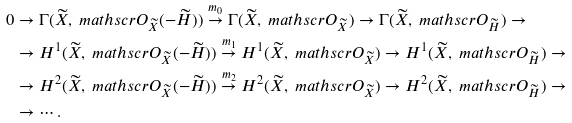<formula> <loc_0><loc_0><loc_500><loc_500>0 & \to \Gamma ( \widetilde { X } , \ m a t h s c r { O } _ { \widetilde { X } } ( - \widetilde { H } ) ) \overset { m _ { 0 } } { \to } \Gamma ( \widetilde { X } , \ m a t h s c r { O } _ { \widetilde { X } } ) \to \Gamma ( \widetilde { X } , \ m a t h s c r { O } _ { \widetilde { H } } ) \to \\ & \to H ^ { 1 } ( \widetilde { X } , \ m a t h s c r { O } _ { \widetilde { X } } ( - \widetilde { H } ) ) \overset { m _ { 1 } } { \to } H ^ { 1 } ( \widetilde { X } , \ m a t h s c r { O } _ { \widetilde { X } } ) \to H ^ { 1 } ( \widetilde { X } , \ m a t h s c r { O } _ { \widetilde { H } } ) \to \\ & \to H ^ { 2 } ( \widetilde { X } , \ m a t h s c r { O } _ { \widetilde { X } } ( - \widetilde { H } ) ) \overset { m _ { 2 } } { \to } H ^ { 2 } ( \widetilde { X } , \ m a t h s c r { O } _ { \widetilde { X } } ) \to H ^ { 2 } ( \widetilde { X } , \ m a t h s c r { O } _ { \widetilde { H } } ) \to \\ & \to \cdots .</formula> 